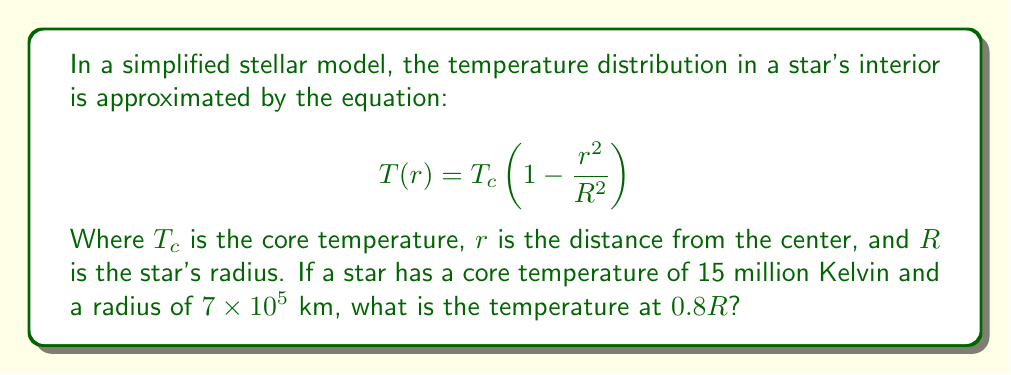What is the answer to this math problem? To solve this problem, we'll follow these steps:

1) We're given:
   $T_c = 15 \times 10^6$ K
   $R = 7 \times 10^5$ km
   We need to find $T(r)$ at $r = 0.8R$

2) Substitute these values into the equation:
   $$T(r) = T_c\left(1 - \frac{r^2}{R^2}\right)$$

3) At $r = 0.8R$, we have:
   $$T(0.8R) = 15 \times 10^6 \left(1 - \frac{(0.8R)^2}{R^2}\right)$$

4) Simplify the fraction inside the parentheses:
   $$T(0.8R) = 15 \times 10^6 \left(1 - \frac{0.64R^2}{R^2}\right)$$
   $$T(0.8R) = 15 \times 10^6 (1 - 0.64)$$

5) Calculate:
   $$T(0.8R) = 15 \times 10^6 \times 0.36$$
   $$T(0.8R) = 5.4 \times 10^6$$ K

Therefore, the temperature at 0.8R is 5.4 million Kelvin.
Answer: 5.4 × 10^6 K 